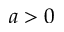<formula> <loc_0><loc_0><loc_500><loc_500>a > 0</formula> 